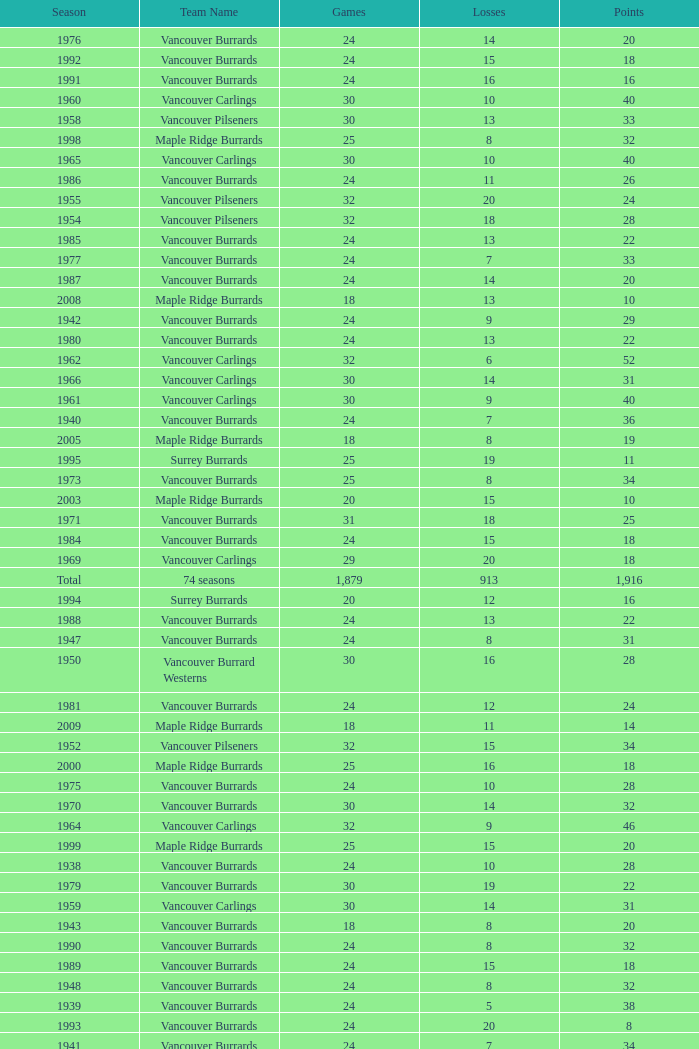Can you parse all the data within this table? {'header': ['Season', 'Team Name', 'Games', 'Losses', 'Points'], 'rows': [['1976', 'Vancouver Burrards', '24', '14', '20'], ['1992', 'Vancouver Burrards', '24', '15', '18'], ['1991', 'Vancouver Burrards', '24', '16', '16'], ['1960', 'Vancouver Carlings', '30', '10', '40'], ['1958', 'Vancouver Pilseners', '30', '13', '33'], ['1998', 'Maple Ridge Burrards', '25', '8', '32'], ['1965', 'Vancouver Carlings', '30', '10', '40'], ['1986', 'Vancouver Burrards', '24', '11', '26'], ['1955', 'Vancouver Pilseners', '32', '20', '24'], ['1954', 'Vancouver Pilseners', '32', '18', '28'], ['1985', 'Vancouver Burrards', '24', '13', '22'], ['1977', 'Vancouver Burrards', '24', '7', '33'], ['1987', 'Vancouver Burrards', '24', '14', '20'], ['2008', 'Maple Ridge Burrards', '18', '13', '10'], ['1942', 'Vancouver Burrards', '24', '9', '29'], ['1980', 'Vancouver Burrards', '24', '13', '22'], ['1962', 'Vancouver Carlings', '32', '6', '52'], ['1966', 'Vancouver Carlings', '30', '14', '31'], ['1961', 'Vancouver Carlings', '30', '9', '40'], ['1940', 'Vancouver Burrards', '24', '7', '36'], ['2005', 'Maple Ridge Burrards', '18', '8', '19'], ['1995', 'Surrey Burrards', '25', '19', '11'], ['1973', 'Vancouver Burrards', '25', '8', '34'], ['2003', 'Maple Ridge Burrards', '20', '15', '10'], ['1971', 'Vancouver Burrards', '31', '18', '25'], ['1984', 'Vancouver Burrards', '24', '15', '18'], ['1969', 'Vancouver Carlings', '29', '20', '18'], ['Total', '74 seasons', '1,879', '913', '1,916'], ['1994', 'Surrey Burrards', '20', '12', '16'], ['1988', 'Vancouver Burrards', '24', '13', '22'], ['1947', 'Vancouver Burrards', '24', '8', '31'], ['1950', 'Vancouver Burrard Westerns', '30', '16', '28'], ['1981', 'Vancouver Burrards', '24', '12', '24'], ['2009', 'Maple Ridge Burrards', '18', '11', '14'], ['1952', 'Vancouver Pilseners', '32', '15', '34'], ['2000', 'Maple Ridge Burrards', '25', '16', '18'], ['1975', 'Vancouver Burrards', '24', '10', '28'], ['1970', 'Vancouver Burrards', '30', '14', '32'], ['1964', 'Vancouver Carlings', '32', '9', '46'], ['1999', 'Maple Ridge Burrards', '25', '15', '20'], ['1938', 'Vancouver Burrards', '24', '10', '28'], ['1979', 'Vancouver Burrards', '30', '19', '22'], ['1959', 'Vancouver Carlings', '30', '14', '31'], ['1943', 'Vancouver Burrards', '18', '8', '20'], ['1990', 'Vancouver Burrards', '24', '8', '32'], ['1989', 'Vancouver Burrards', '24', '15', '18'], ['1948', 'Vancouver Burrards', '24', '8', '32'], ['1939', 'Vancouver Burrards', '24', '5', '38'], ['1993', 'Vancouver Burrards', '24', '20', '8'], ['1941', 'Vancouver Burrards', '24', '7', '34'], ['1944', 'Vancouver Burrards', '24', '14', '20'], ['1946', 'Vancouver Burrards', '24', '11', '25'], ['1949', 'Vancouver Burrards', '16', '7', '18'], ['1957', 'Vancouver Pilseners', '30', '20', '20'], ['1953', 'Vancouver Pilseners', '32', '12', '39'], ['1972', 'Vancouver Burrards', '36', '17', '38'], ['1974', 'Vancouver Burrards', '24', '13', '22'], ['2004', 'Maple Ridge Burrards', '20', '12', '16'], ['1937', 'Vancouver Burrard Olympics', '28', '20', '16'], ['1978', 'Vancouver Burrards', '24', '13', '22'], ['1968', 'Vancouver Carlings', '38', '16', '44'], ['2002', 'Maple Ridge Burrards', '20', '15', '8'], ['2006', 'Maple Ridge Burrards', '18', '11', '14'], ['1983', 'Vancouver Burrards', '24', '10', '28'], ['1945', 'Vancouver Burrards', '24', '4', '40'], ['2001', 'Maple Ridge Burrards', '20', '16', '8'], ['1996', 'Maple Ridge Burrards', '20', '8', '23'], ['2007', 'Maple Ridge Burrards', '18', '11', '14'], ['1997', 'Maple Ridge Burrards', '20', '8', '23'], ['1956', 'Vancouver Pilseners', '30', '13', '33'], ['2010', 'Maple Ridge Burrards', '18', '9', '18'], ['1982', 'Vancouver Burrards', '24', '12', '24'], ['1951', 'Vancouver Combines', '32', '14', '35'], ['1963', 'Vancouver Carlings', '30', '7', '45'], ['1967', 'Vancouver Carlings', '30', '12', '34']]} What's the total number of games with more than 20 points for the 1976 season? 0.0. 